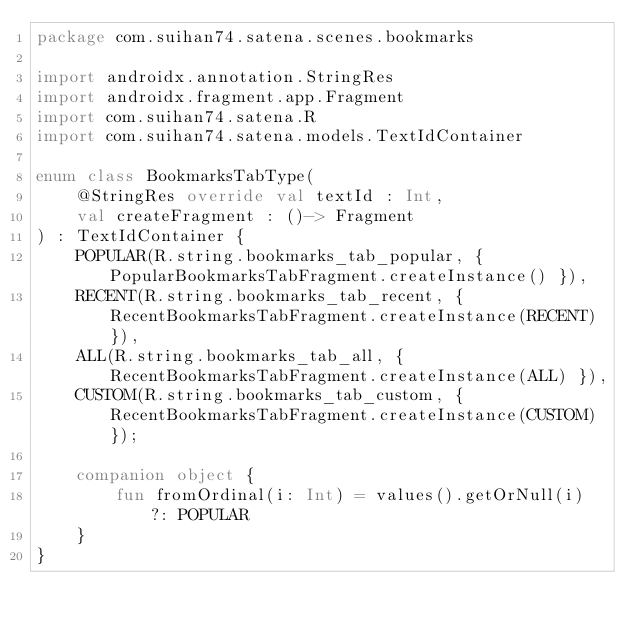Convert code to text. <code><loc_0><loc_0><loc_500><loc_500><_Kotlin_>package com.suihan74.satena.scenes.bookmarks

import androidx.annotation.StringRes
import androidx.fragment.app.Fragment
import com.suihan74.satena.R
import com.suihan74.satena.models.TextIdContainer

enum class BookmarksTabType(
    @StringRes override val textId : Int,
    val createFragment : ()-> Fragment
) : TextIdContainer {
    POPULAR(R.string.bookmarks_tab_popular, { PopularBookmarksTabFragment.createInstance() }),
    RECENT(R.string.bookmarks_tab_recent, { RecentBookmarksTabFragment.createInstance(RECENT) }),
    ALL(R.string.bookmarks_tab_all, { RecentBookmarksTabFragment.createInstance(ALL) }),
    CUSTOM(R.string.bookmarks_tab_custom, { RecentBookmarksTabFragment.createInstance(CUSTOM) });

    companion object {
        fun fromOrdinal(i: Int) = values().getOrNull(i) ?: POPULAR
    }
}
</code> 